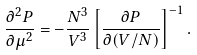Convert formula to latex. <formula><loc_0><loc_0><loc_500><loc_500>\frac { \partial ^ { 2 } P } { \partial \mu ^ { 2 } } = - \frac { N ^ { 3 } } { V ^ { 3 } } \left [ \frac { \partial P } { \partial ( V / N ) } \right ] ^ { - 1 } .</formula> 